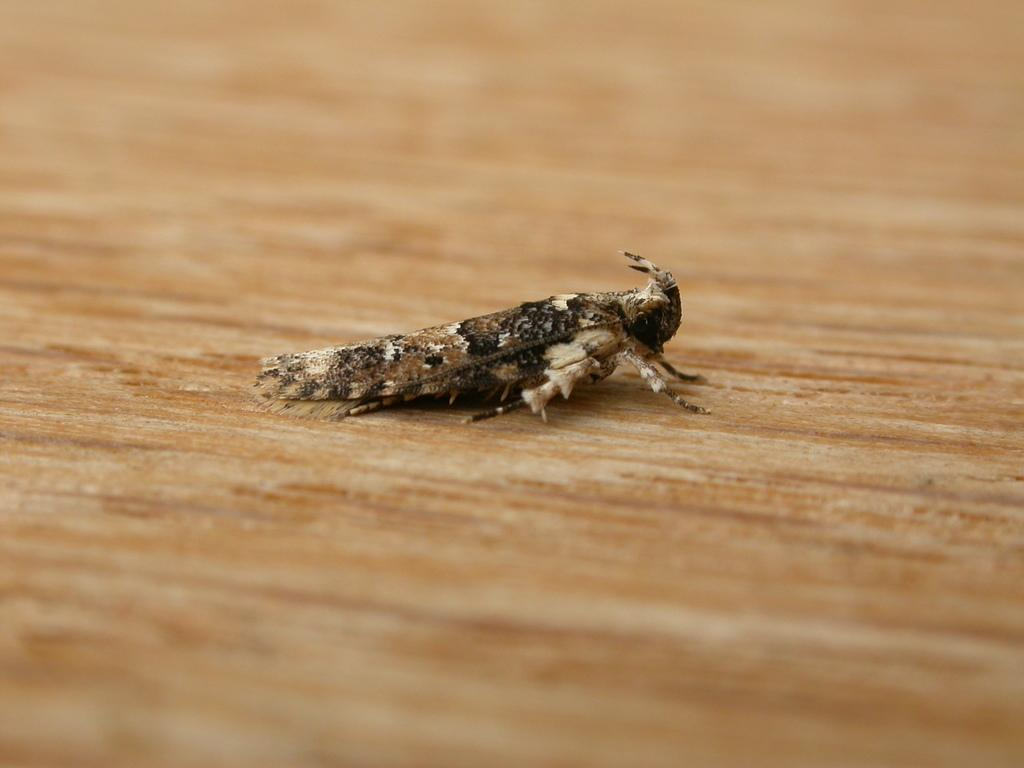What is the main subject of the image? The main subject of the image is a fly. Where is the fly located in the image? The fly is in the center of the image. What is the color of the surface the fly is on? The fly is on a brown-colored surface. What type of request can be seen in the image? There is no request present in the image; it features a fly in the center of a brown-colored surface. How many cents are visible in the image? There are no cents present in the image. 